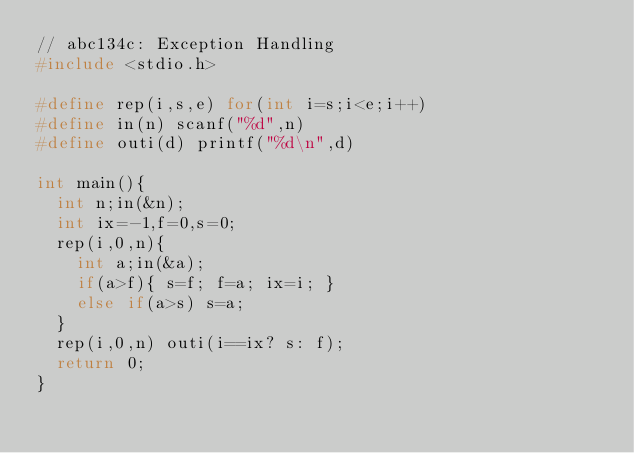Convert code to text. <code><loc_0><loc_0><loc_500><loc_500><_C_>// abc134c: Exception Handling
#include <stdio.h>

#define rep(i,s,e) for(int i=s;i<e;i++)
#define in(n) scanf("%d",n)
#define outi(d) printf("%d\n",d)

int main(){
  int n;in(&n);
  int ix=-1,f=0,s=0;
  rep(i,0,n){
    int a;in(&a);
    if(a>f){ s=f; f=a; ix=i; }
    else if(a>s) s=a;
  }
  rep(i,0,n) outi(i==ix? s: f);
  return 0;
}</code> 